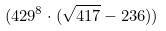<formula> <loc_0><loc_0><loc_500><loc_500>( 4 2 9 ^ { 8 } \cdot ( \sqrt { 4 1 7 } - 2 3 6 ) )</formula> 